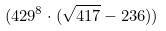<formula> <loc_0><loc_0><loc_500><loc_500>( 4 2 9 ^ { 8 } \cdot ( \sqrt { 4 1 7 } - 2 3 6 ) )</formula> 